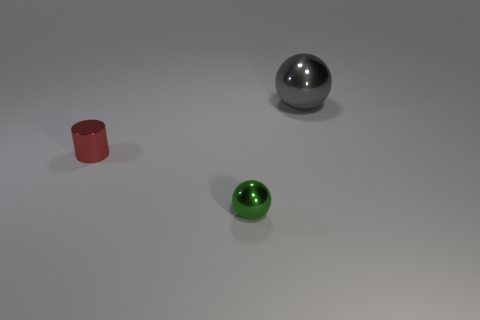There is a thing that is on the right side of the green object; is it the same shape as the tiny object that is behind the tiny green sphere?
Provide a short and direct response. No. What size is the thing that is both on the right side of the small red shiny cylinder and behind the tiny shiny ball?
Provide a short and direct response. Large. There is another small thing that is the same shape as the gray object; what is its color?
Provide a short and direct response. Green. There is a tiny cylinder left of the metallic ball that is left of the big gray ball; what is its color?
Ensure brevity in your answer.  Red. There is a green thing; what shape is it?
Ensure brevity in your answer.  Sphere. The thing that is left of the gray metallic sphere and to the right of the small red metal thing has what shape?
Ensure brevity in your answer.  Sphere. The small cylinder that is made of the same material as the big gray object is what color?
Offer a very short reply. Red. What shape is the metal thing that is behind the small thing behind the shiny sphere that is in front of the big ball?
Your answer should be very brief. Sphere. The red metallic cylinder has what size?
Offer a terse response. Small. What is the shape of the small red object that is the same material as the large gray sphere?
Make the answer very short. Cylinder. 